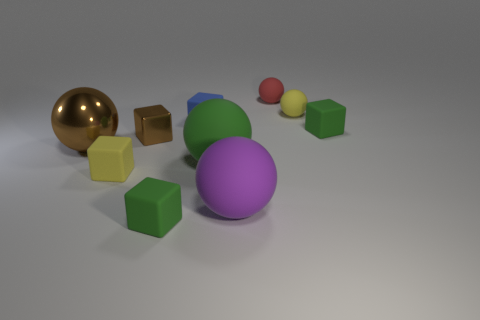Subtract all metallic spheres. How many spheres are left? 4 Subtract all red cylinders. How many green cubes are left? 2 Subtract all yellow spheres. How many spheres are left? 4 Subtract all brown spheres. Subtract all green cubes. How many spheres are left? 4 Subtract 0 cyan blocks. How many objects are left? 10 Subtract all big brown balls. Subtract all purple balls. How many objects are left? 8 Add 3 big things. How many big things are left? 6 Add 8 large rubber spheres. How many large rubber spheres exist? 10 